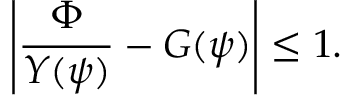<formula> <loc_0><loc_0><loc_500><loc_500>\left | \frac { \Phi } { Y ( \psi ) } - G ( \psi ) \right | \leq 1 .</formula> 